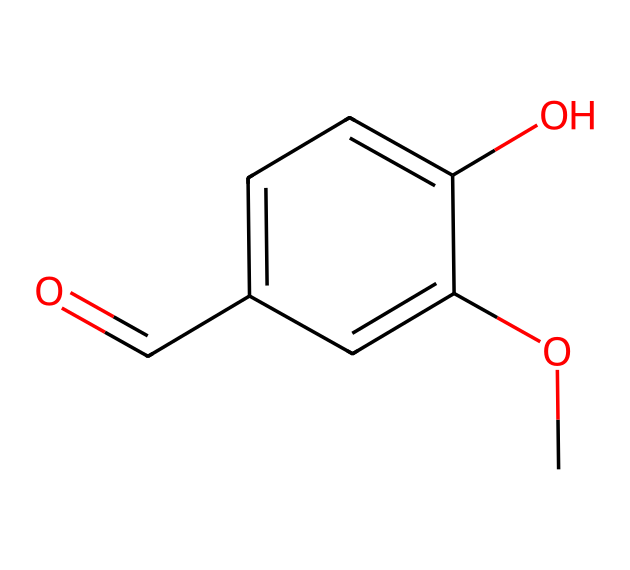How many carbon atoms are in vanillin? The SMILES representation shows "C" for carbon atoms. Counting the "C" characters reveals there are 8 carbon atoms in total.
Answer: 8 What functional groups are present in vanillin? The SMILES notation includes an aldehyde group (C=O) and a methoxy group (O-CH3), along with the hydroxyl group (-OH) on the aromatic ring.
Answer: aldehyde, methoxy, hydroxyl What is the molecular formula of vanillin? By interpreting the SMILES, we can deduce that vanillin has 8 carbon atoms, 8 hydrogen atoms, and 3 oxygen atoms, leading to the molecular formula C8H8O3.
Answer: C8H8O3 Which part of the molecule indicates its sweetness? Vanillin is known for its sweet aroma, primarily due to the presence of the aldehyde functional group (C=O). The carbonyl in aldehydes is often associated with sweet scents.
Answer: aldehyde How many rings are present in vanillin's structure? The structure of vanillin contains one aromatic ring, which can be identified by the 'c' characters in the SMILES that signify aromatic carbon atoms.
Answer: 1 What is the significance of the -O-CH3 group in vanillin? The -O-CH3 group, also known as a methoxy group, contributes to the molecule's solubility in organic solvents and affects its fragrance profile by enhancing its sweetness and aroma.
Answer: methoxy group Why is vanillin classified as an aldehyde? Vanillin contains a functional group specifically characterized by a carbonyl group bonded to a terminal carbon atom, making it an aldehyde. This is evident from the C=O bond structure in the SMILES notation.
Answer: aldehyde 